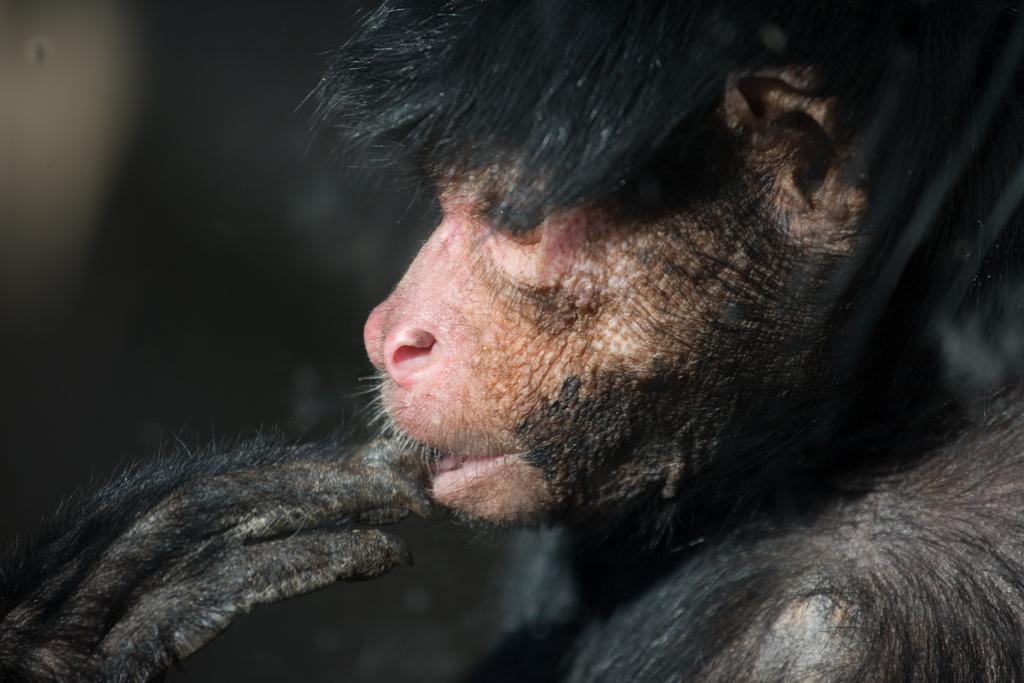Could you give a brief overview of what you see in this image? In this image we can see an animal and the background is dark. 